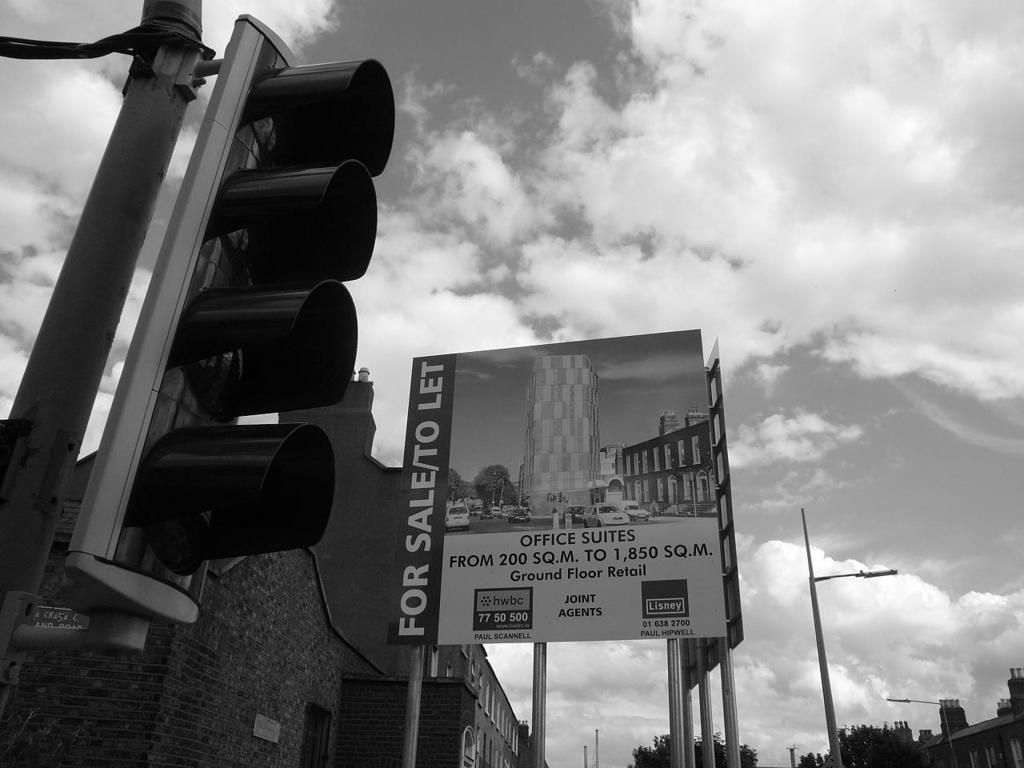<image>
Provide a brief description of the given image. A large billboard reading "for sale" stands behind of a traffic light. 